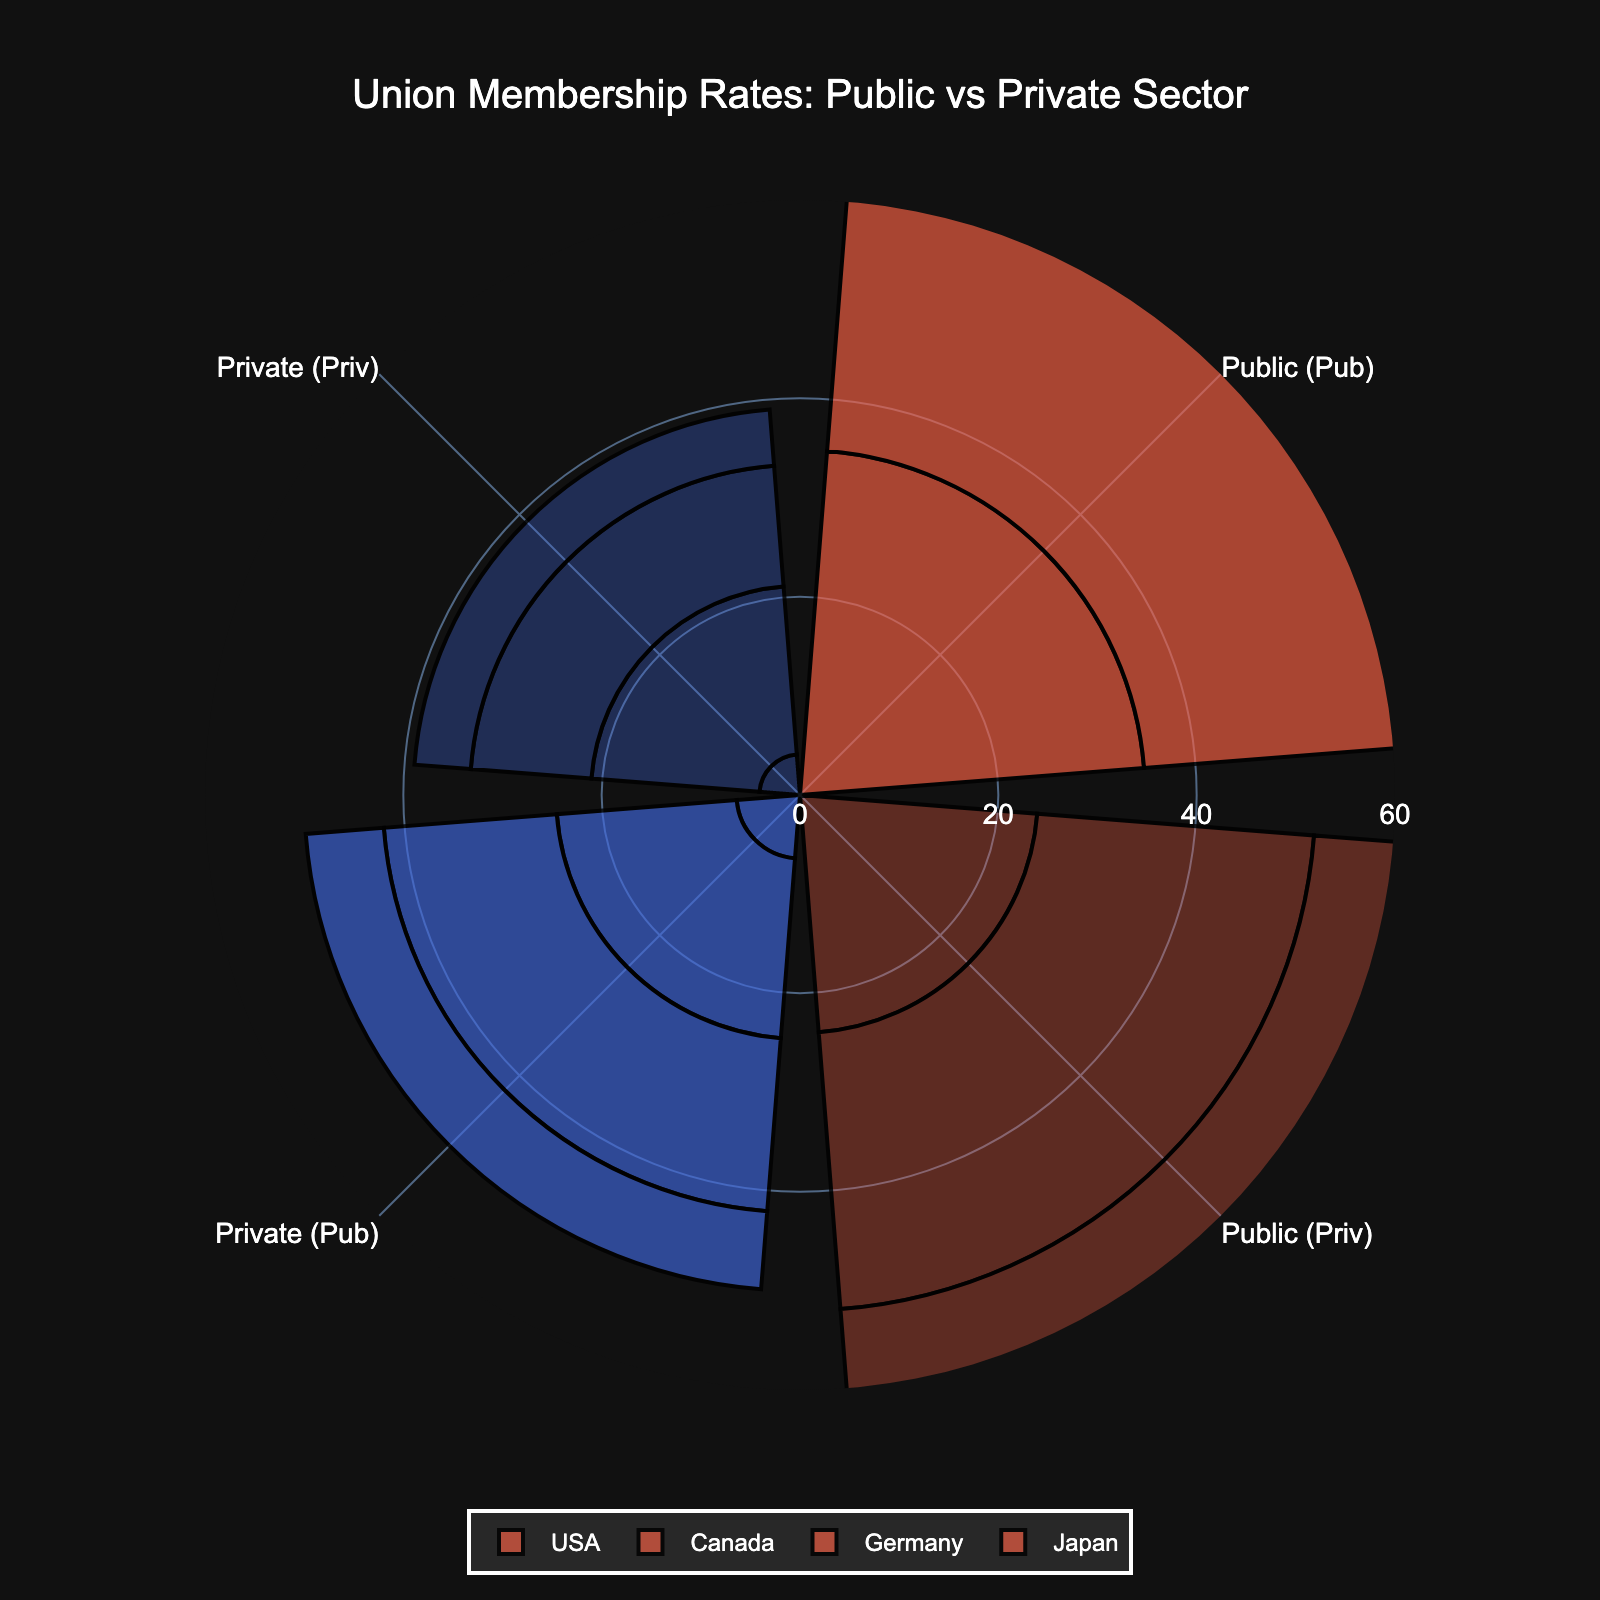How many countries are represented in the chart? To find how many countries are represented, look at the number of legends or country names on the plot. The given data lists four countries: USA, Canada, Germany, and Japan.
Answer: 4 Which country has the highest private sector union membership rate? By locating the specific sector (Private Sector) and comparing the highlighted values, Canada has the highest private sector union membership rate at 28.0%.
Answer: Canada What is the difference between public and private sector union membership rates in Germany? From the chart, identify the union membership rates for both sectors in Germany: Public Sector is 48.9%, and Private Sector is 18.3%. Subtract the private rate from the public rate (48.9 - 18.3).
Answer: 30.6% What are the two lowest public sector union membership rates, and which countries do they belong to? By scanning the public sector segments, the lowest rates belong to Japan at 18.7% and the USA at 34.8%.
Answer: Japan and USA Which sector generally has higher union membership rates across all countries? Observe the trend in each segment for both public and private sectors across all provided countries. The public sector rates are consistently higher than the private sector rates.
Answer: Public Sector For which country is the difference between public sector and private sector union membership rates the smallest? Compare the differences between public and private rates for all countries. Japan shows the smallest difference between public (18.7%) and private (12.0%) sectors.
Answer: Japan What is the average public sector union membership rate among all represented countries? Add all public sector rates (34.8, 54.1, 48.9, 18.7) and divide by the number of countries (4). (34.8 + 54.1 + 48.9 + 18.7) / 4 = 39.125.
Answer: 39.1% Which country has the largest gap between public sector and private sector union membership rates in the private sector? Observe the rates in the private sector for each country and calculate the differences between public and private rates within the private sector. The USA has the largest gap with 24.0% in Public (Priv) vs 4.1% in Private (Priv), a difference of 19.9%.
Answer: USA 